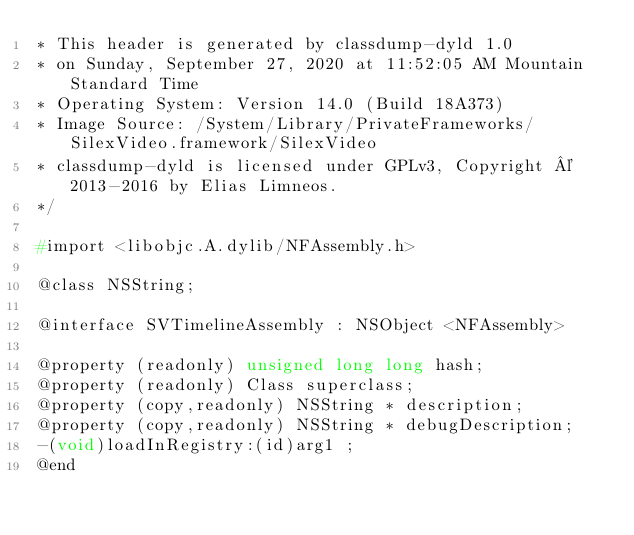<code> <loc_0><loc_0><loc_500><loc_500><_C_>* This header is generated by classdump-dyld 1.0
* on Sunday, September 27, 2020 at 11:52:05 AM Mountain Standard Time
* Operating System: Version 14.0 (Build 18A373)
* Image Source: /System/Library/PrivateFrameworks/SilexVideo.framework/SilexVideo
* classdump-dyld is licensed under GPLv3, Copyright © 2013-2016 by Elias Limneos.
*/

#import <libobjc.A.dylib/NFAssembly.h>

@class NSString;

@interface SVTimelineAssembly : NSObject <NFAssembly>

@property (readonly) unsigned long long hash; 
@property (readonly) Class superclass; 
@property (copy,readonly) NSString * description; 
@property (copy,readonly) NSString * debugDescription; 
-(void)loadInRegistry:(id)arg1 ;
@end

</code> 